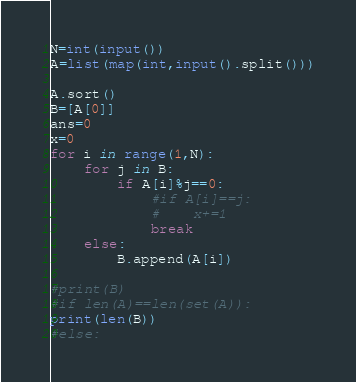Convert code to text. <code><loc_0><loc_0><loc_500><loc_500><_Python_>N=int(input())
A=list(map(int,input().split()))

A.sort()
B=[A[0]]
ans=0
x=0
for i in range(1,N):
    for j in B:
        if A[i]%j==0:
            #if A[i]==j:
            #    x+=1
            break
    else:
        B.append(A[i])

#print(B)
#if len(A)==len(set(A)):
print(len(B))
#else:
</code> 